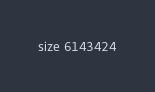Convert code to text. <code><loc_0><loc_0><loc_500><loc_500><_YAML_>size 6143424
</code> 